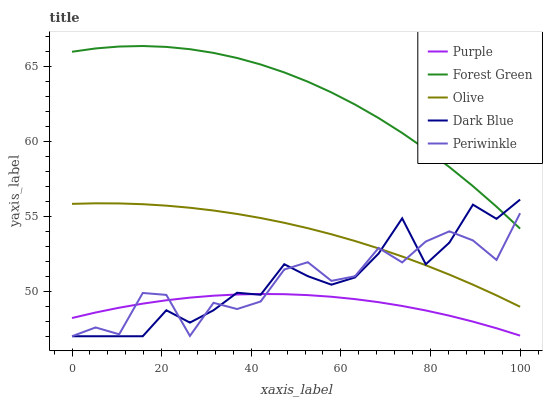Does Olive have the minimum area under the curve?
Answer yes or no. No. Does Olive have the maximum area under the curve?
Answer yes or no. No. Is Forest Green the smoothest?
Answer yes or no. No. Is Forest Green the roughest?
Answer yes or no. No. Does Olive have the lowest value?
Answer yes or no. No. Does Olive have the highest value?
Answer yes or no. No. Is Purple less than Olive?
Answer yes or no. Yes. Is Forest Green greater than Olive?
Answer yes or no. Yes. Does Purple intersect Olive?
Answer yes or no. No. 